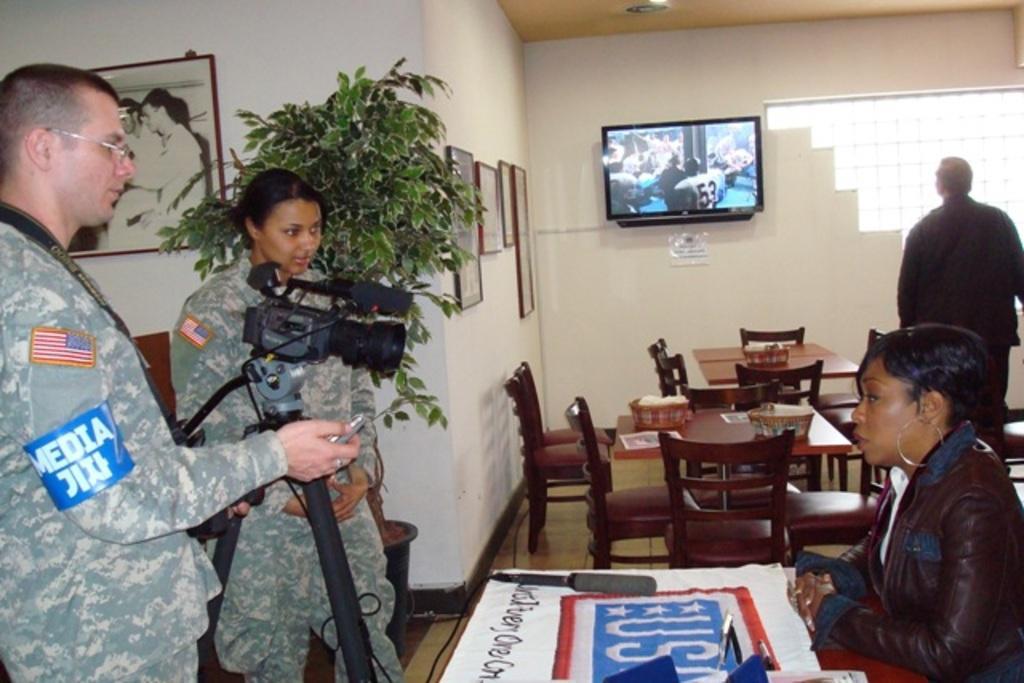In one or two sentences, can you explain what this image depicts? In this picture we can see two persons standing on the floor. This is the camera. And she is sitting on the chair. This is table, and there are many chairs on the floor. Here we can see a man who is standing and looking in to the screen. This is the wall, and there are many frames on to the wall. And this is the plant. 